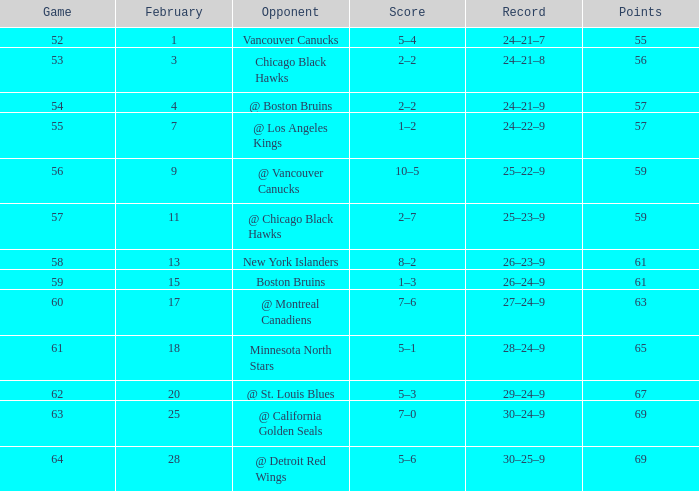How many february games had a record of 29–24–9? 20.0. 